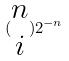<formula> <loc_0><loc_0><loc_500><loc_500>( \begin{matrix} n \\ i \end{matrix} ) 2 ^ { - n }</formula> 